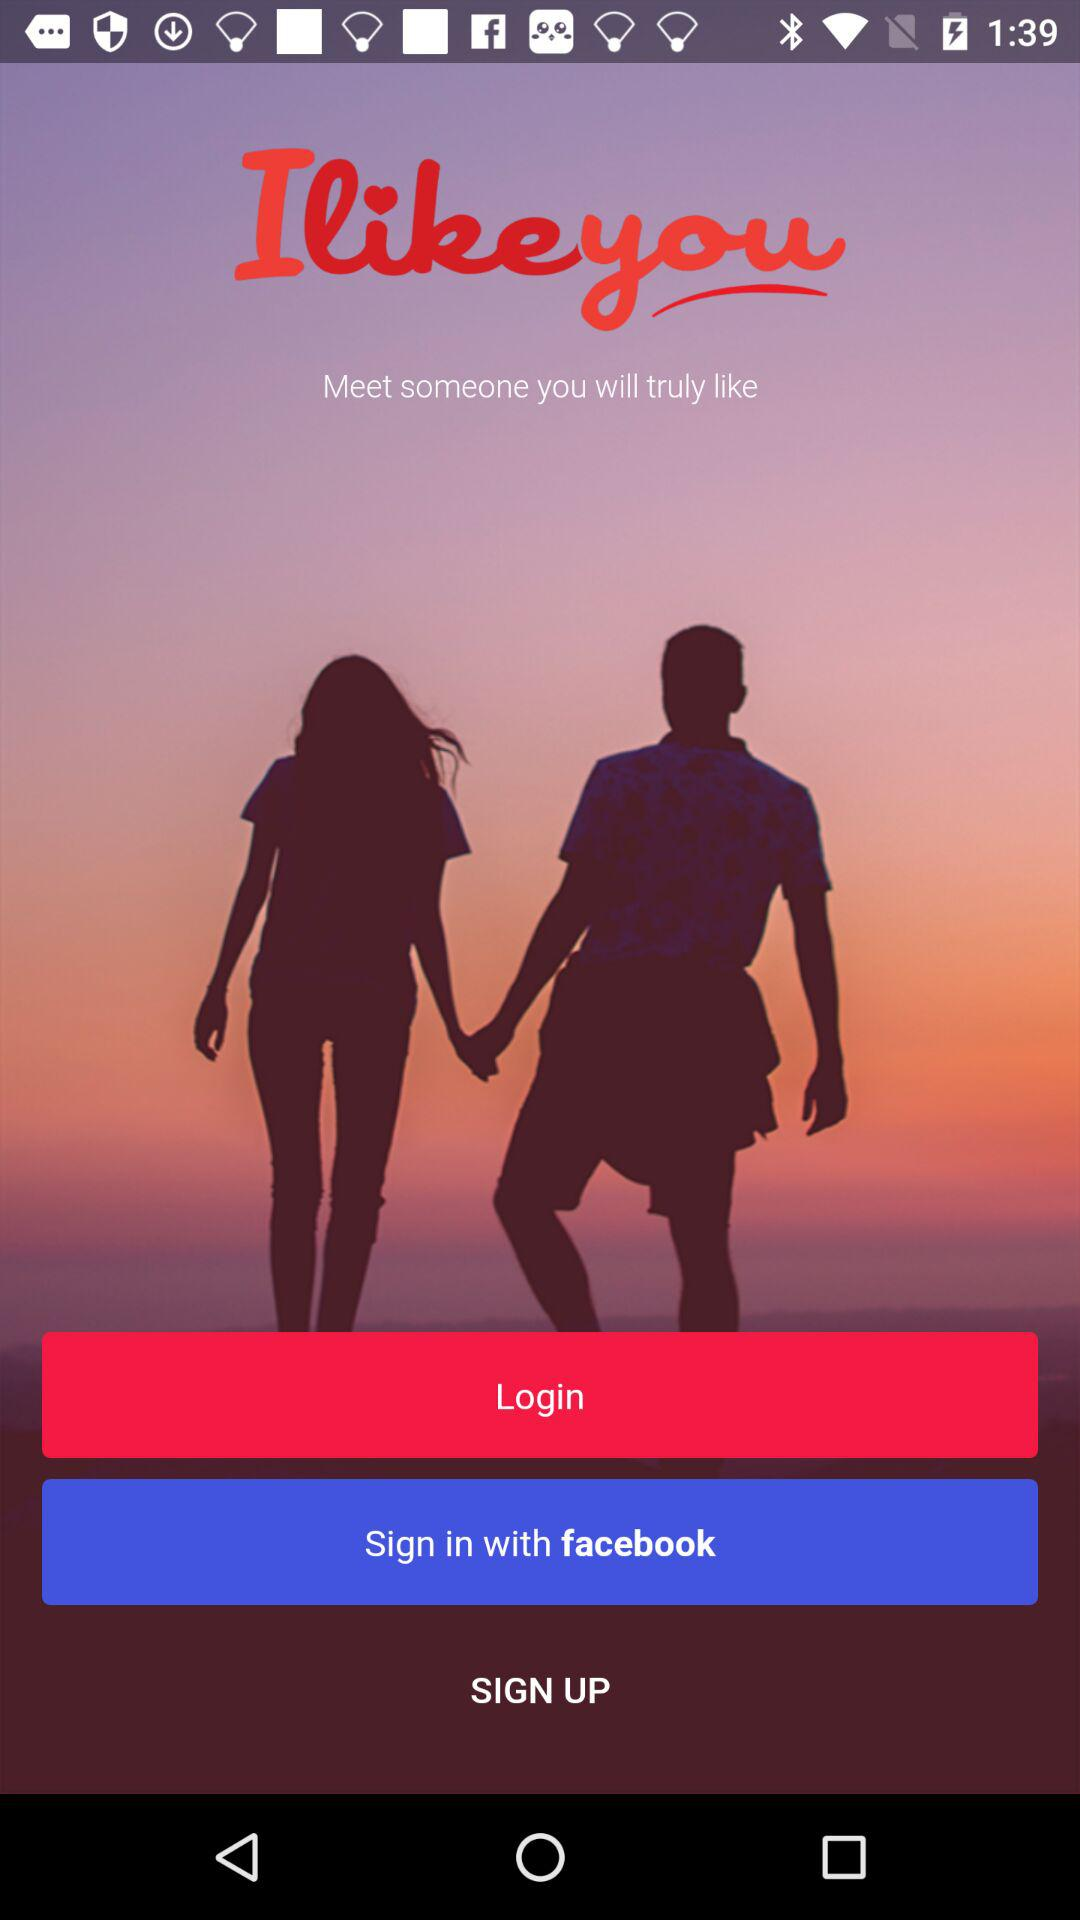What is the application name? The application name is "Ilikeyou". 